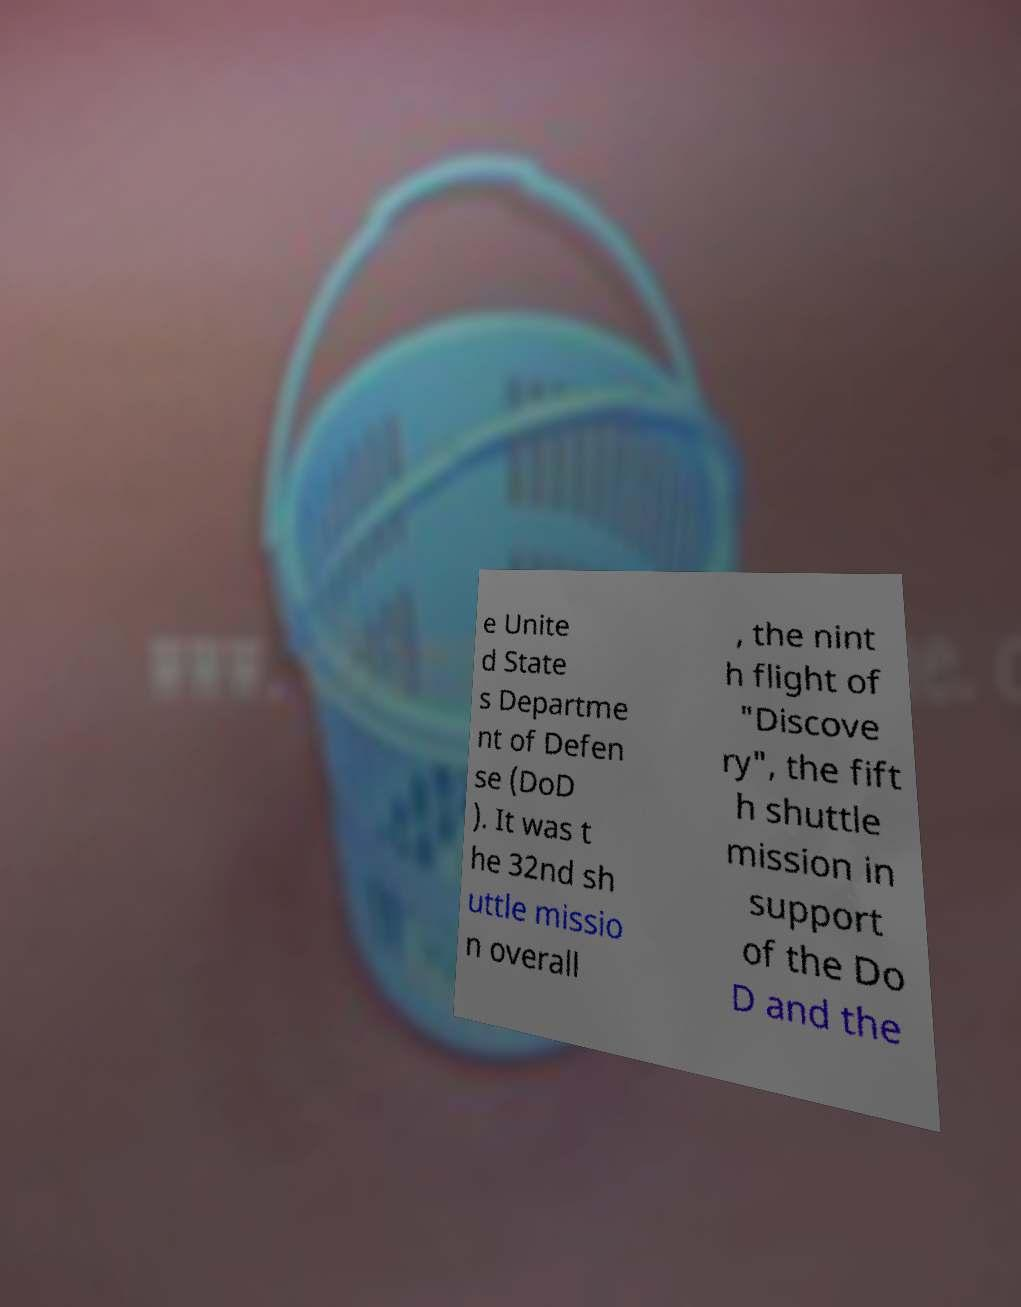For documentation purposes, I need the text within this image transcribed. Could you provide that? e Unite d State s Departme nt of Defen se (DoD ). It was t he 32nd sh uttle missio n overall , the nint h flight of "Discove ry", the fift h shuttle mission in support of the Do D and the 